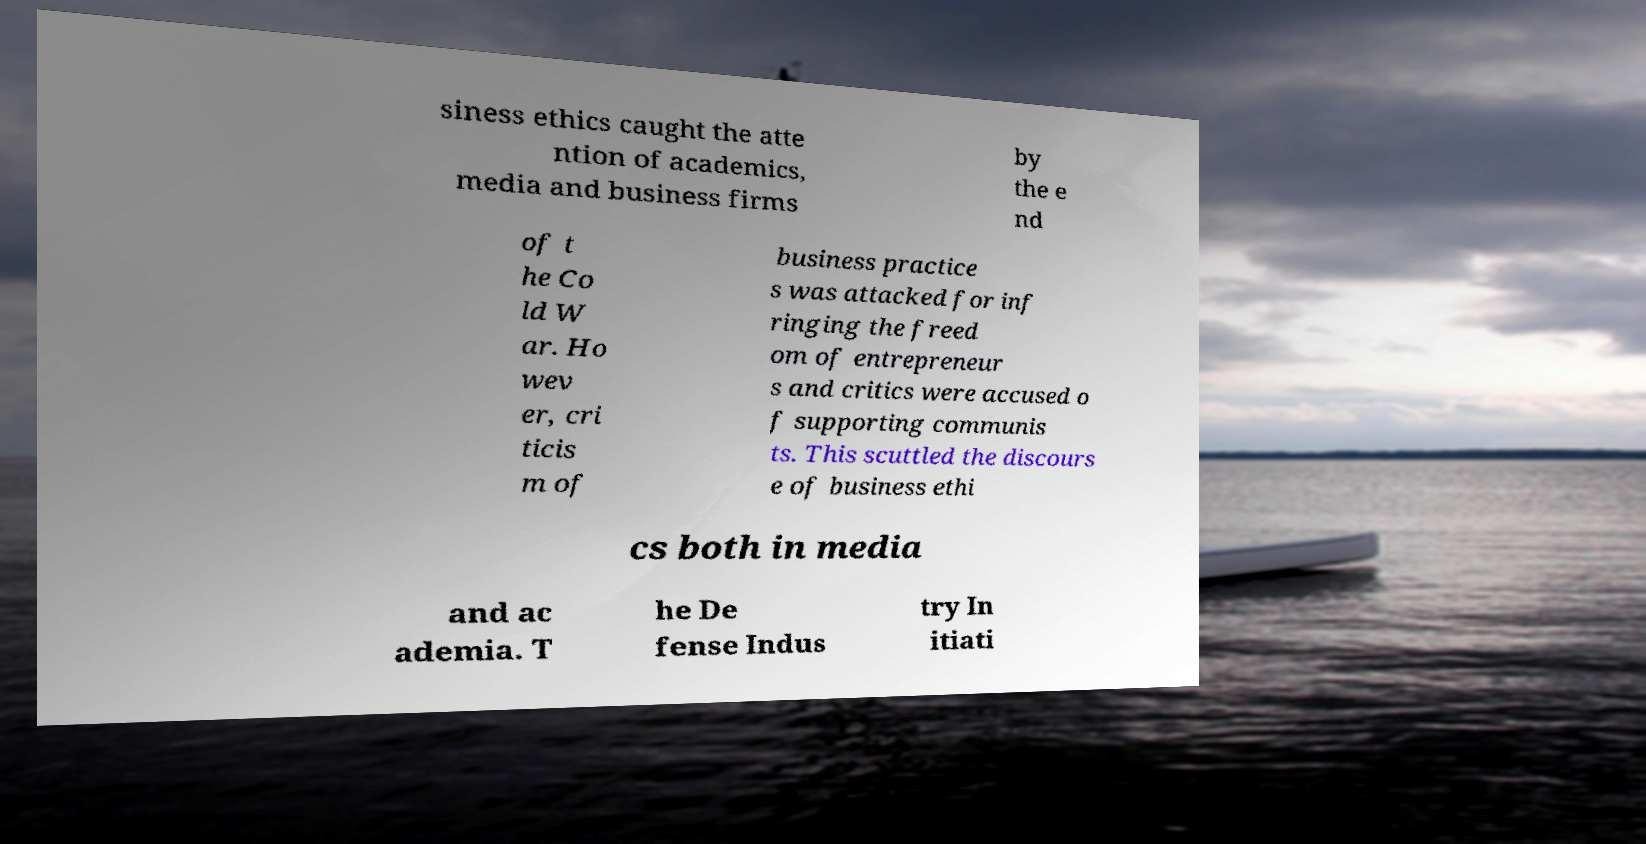Can you accurately transcribe the text from the provided image for me? siness ethics caught the atte ntion of academics, media and business firms by the e nd of t he Co ld W ar. Ho wev er, cri ticis m of business practice s was attacked for inf ringing the freed om of entrepreneur s and critics were accused o f supporting communis ts. This scuttled the discours e of business ethi cs both in media and ac ademia. T he De fense Indus try In itiati 